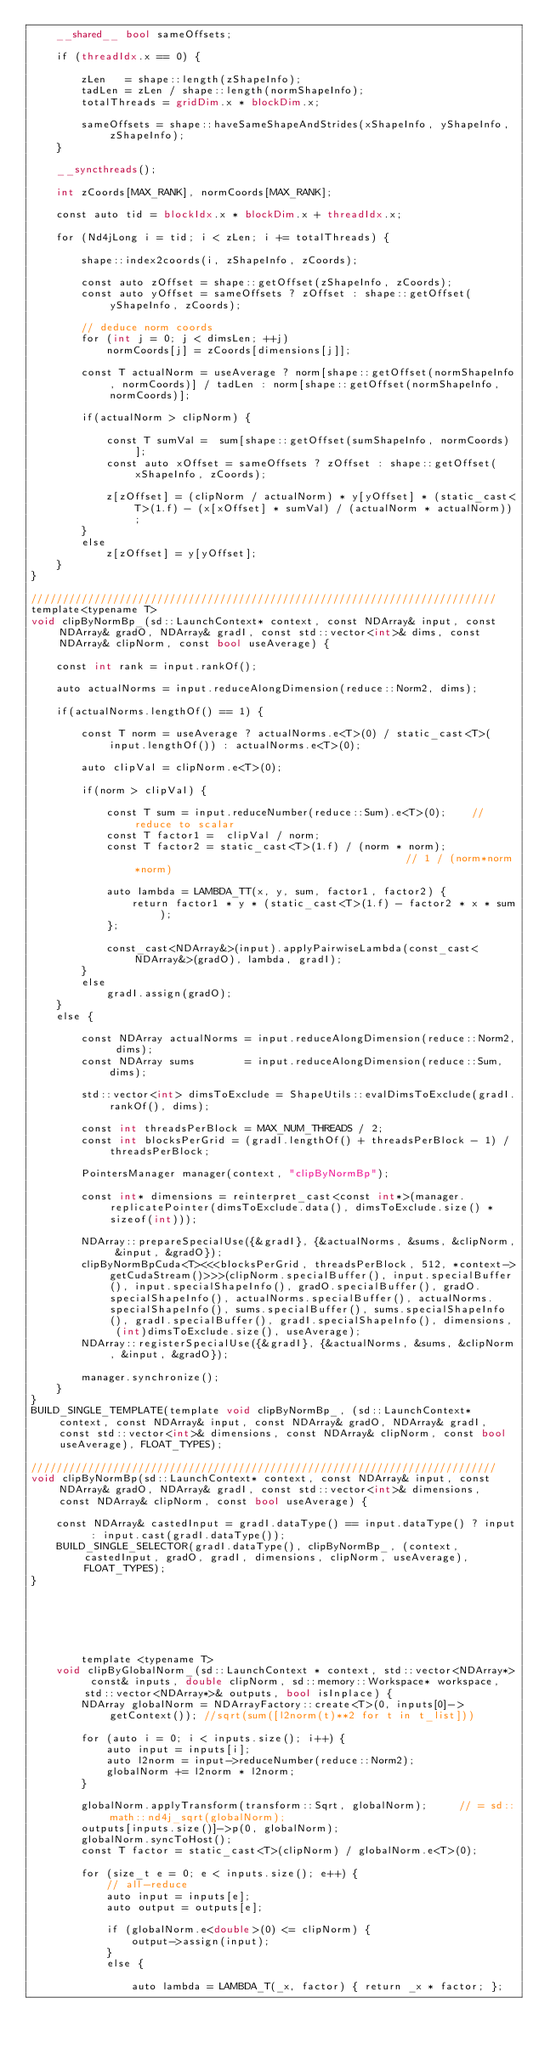Convert code to text. <code><loc_0><loc_0><loc_500><loc_500><_Cuda_>    __shared__ bool sameOffsets;

    if (threadIdx.x == 0) {

        zLen   = shape::length(zShapeInfo);
        tadLen = zLen / shape::length(normShapeInfo);
        totalThreads = gridDim.x * blockDim.x;

        sameOffsets = shape::haveSameShapeAndStrides(xShapeInfo, yShapeInfo, zShapeInfo);
    }

    __syncthreads();

    int zCoords[MAX_RANK], normCoords[MAX_RANK];

    const auto tid = blockIdx.x * blockDim.x + threadIdx.x;

    for (Nd4jLong i = tid; i < zLen; i += totalThreads) {

        shape::index2coords(i, zShapeInfo, zCoords);

        const auto zOffset = shape::getOffset(zShapeInfo, zCoords);
        const auto yOffset = sameOffsets ? zOffset : shape::getOffset(yShapeInfo, zCoords);

        // deduce norm coords
        for (int j = 0; j < dimsLen; ++j)
            normCoords[j] = zCoords[dimensions[j]];

        const T actualNorm = useAverage ? norm[shape::getOffset(normShapeInfo, normCoords)] / tadLen : norm[shape::getOffset(normShapeInfo, normCoords)];

        if(actualNorm > clipNorm) {

            const T sumVal =  sum[shape::getOffset(sumShapeInfo, normCoords)];
            const auto xOffset = sameOffsets ? zOffset : shape::getOffset(xShapeInfo, zCoords);

            z[zOffset] = (clipNorm / actualNorm) * y[yOffset] * (static_cast<T>(1.f) - (x[xOffset] * sumVal) / (actualNorm * actualNorm));
        }
        else
            z[zOffset] = y[yOffset];
    }
}

//////////////////////////////////////////////////////////////////////////
template<typename T>
void clipByNormBp_(sd::LaunchContext* context, const NDArray& input, const NDArray& gradO, NDArray& gradI, const std::vector<int>& dims, const NDArray& clipNorm, const bool useAverage) {

    const int rank = input.rankOf();

    auto actualNorms = input.reduceAlongDimension(reduce::Norm2, dims);

    if(actualNorms.lengthOf() == 1) {

        const T norm = useAverage ? actualNorms.e<T>(0) / static_cast<T>(input.lengthOf()) : actualNorms.e<T>(0);

        auto clipVal = clipNorm.e<T>(0);

        if(norm > clipVal) {

            const T sum = input.reduceNumber(reduce::Sum).e<T>(0);    // reduce to scalar
            const T factor1 =  clipVal / norm;
            const T factor2 = static_cast<T>(1.f) / (norm * norm);                                            // 1 / (norm*norm*norm)

            auto lambda = LAMBDA_TT(x, y, sum, factor1, factor2) {
                return factor1 * y * (static_cast<T>(1.f) - factor2 * x * sum);
            };

            const_cast<NDArray&>(input).applyPairwiseLambda(const_cast<NDArray&>(gradO), lambda, gradI);
        }
        else
            gradI.assign(gradO);
    }
    else {

        const NDArray actualNorms = input.reduceAlongDimension(reduce::Norm2, dims);
        const NDArray sums        = input.reduceAlongDimension(reduce::Sum, dims);

        std::vector<int> dimsToExclude = ShapeUtils::evalDimsToExclude(gradI.rankOf(), dims);

        const int threadsPerBlock = MAX_NUM_THREADS / 2;
        const int blocksPerGrid = (gradI.lengthOf() + threadsPerBlock - 1) / threadsPerBlock;

        PointersManager manager(context, "clipByNormBp");

        const int* dimensions = reinterpret_cast<const int*>(manager.replicatePointer(dimsToExclude.data(), dimsToExclude.size() * sizeof(int)));

        NDArray::prepareSpecialUse({&gradI}, {&actualNorms, &sums, &clipNorm, &input, &gradO});
        clipByNormBpCuda<T><<<blocksPerGrid, threadsPerBlock, 512, *context->getCudaStream()>>>(clipNorm.specialBuffer(), input.specialBuffer(), input.specialShapeInfo(), gradO.specialBuffer(), gradO.specialShapeInfo(), actualNorms.specialBuffer(), actualNorms.specialShapeInfo(), sums.specialBuffer(), sums.specialShapeInfo(), gradI.specialBuffer(), gradI.specialShapeInfo(), dimensions, (int)dimsToExclude.size(), useAverage);
        NDArray::registerSpecialUse({&gradI}, {&actualNorms, &sums, &clipNorm, &input, &gradO});

        manager.synchronize();
    }
}
BUILD_SINGLE_TEMPLATE(template void clipByNormBp_, (sd::LaunchContext* context, const NDArray& input, const NDArray& gradO, NDArray& gradI, const std::vector<int>& dimensions, const NDArray& clipNorm, const bool useAverage), FLOAT_TYPES);

//////////////////////////////////////////////////////////////////////////
void clipByNormBp(sd::LaunchContext* context, const NDArray& input, const NDArray& gradO, NDArray& gradI, const std::vector<int>& dimensions, const NDArray& clipNorm, const bool useAverage) {

    const NDArray& castedInput = gradI.dataType() == input.dataType() ? input : input.cast(gradI.dataType());
    BUILD_SINGLE_SELECTOR(gradI.dataType(), clipByNormBp_, (context, castedInput, gradO, gradI, dimensions, clipNorm, useAverage), FLOAT_TYPES);
}






        template <typename T>
    void clipByGlobalNorm_(sd::LaunchContext * context, std::vector<NDArray*> const& inputs, double clipNorm, sd::memory::Workspace* workspace, std::vector<NDArray*>& outputs, bool isInplace) {
        NDArray globalNorm = NDArrayFactory::create<T>(0, inputs[0]->getContext()); //sqrt(sum([l2norm(t)**2 for t in t_list]))

        for (auto i = 0; i < inputs.size(); i++) {
            auto input = inputs[i];
            auto l2norm = input->reduceNumber(reduce::Norm2);
            globalNorm += l2norm * l2norm;
        }

        globalNorm.applyTransform(transform::Sqrt, globalNorm);     // = sd::math::nd4j_sqrt(globalNorm);
        outputs[inputs.size()]->p(0, globalNorm);
        globalNorm.syncToHost();
        const T factor = static_cast<T>(clipNorm) / globalNorm.e<T>(0);

        for (size_t e = 0; e < inputs.size(); e++) {
            // all-reduce
            auto input = inputs[e];
            auto output = outputs[e];

            if (globalNorm.e<double>(0) <= clipNorm) {
                output->assign(input);
            }
            else {

                auto lambda = LAMBDA_T(_x, factor) { return _x * factor; };</code> 